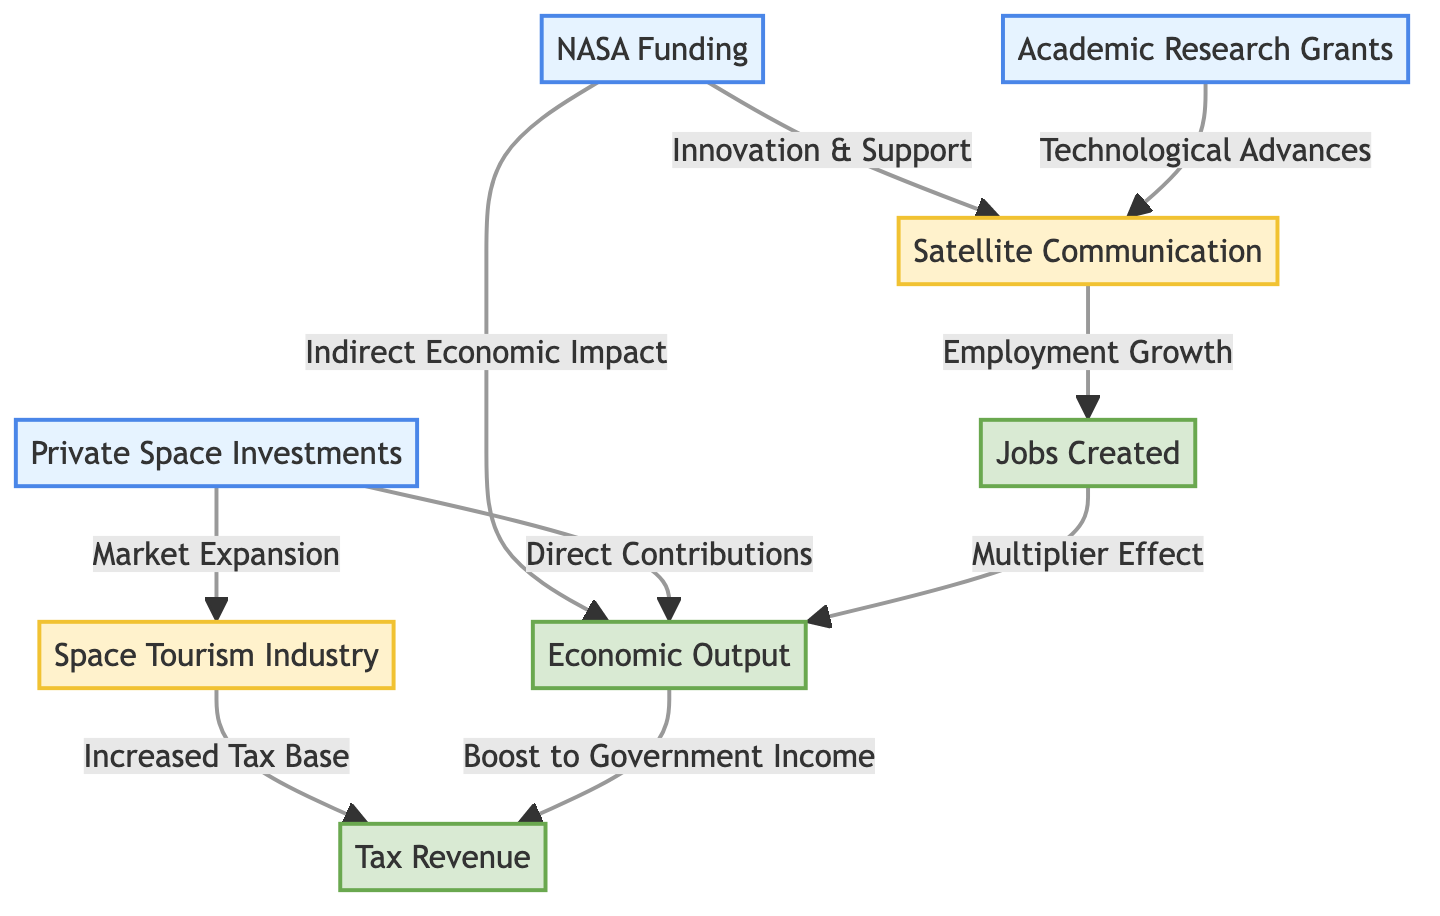What is the main source of funding represented in the diagram? The diagram highlights "NASA Funding" as the primary source of funding, indicated at the top with arrows pointing to various related industries and economic outputs.
Answer: NASA Funding Which industry benefits directly from private space investments? The diagram shows that "Space Tourism Industry" benefits directly from "Private Space Investments," as indicated by the direct arrow linking the two.
Answer: Space Tourism Industry How many types of economic outputs are depicted in the diagram? The diagram shows three types of economic outputs: "Economic Output," "Jobs Created," and "Tax Revenue." Counting these nodes confirms there are three distinct outputs.
Answer: Three What is the relationship between satellite communication and jobs created? According to the diagram, there is an arrow indicating that "Satellite Communication" contributes to "Jobs Created," illustrating an employment growth relationship stemming from the industry.
Answer: Employment Growth How does economic output affect tax revenue according to the diagram? The diagram illustrates that "Economic Output" boosts "Tax Revenue," indicating a direct financial relationship where increased economic activities lead to higher tax income for the government.
Answer: Boost to Government Income Which sector is associated with technological advances based on academic research? The diagram indicates that "Satellite Communication" is the sector associated with "Technological Advances" stemming from "Academic Research Grants," highlighting the link between research and industry.
Answer: Satellite Communication What multiplier effect is described in the diagram? The diagram illustrates that "Jobs Created" has a "Multiplier Effect" on "Economic Output," indicating that the creation of jobs can lead to increases in overall economic activities.
Answer: Multiplier Effect What role does private space investment play in the economy based on the diagram? The diagram links "Private Space Investments" to "Economic Output" through "Direct Contributions," showing that investments in the private sector lead directly to economic benefits.
Answer: Direct Contributions 